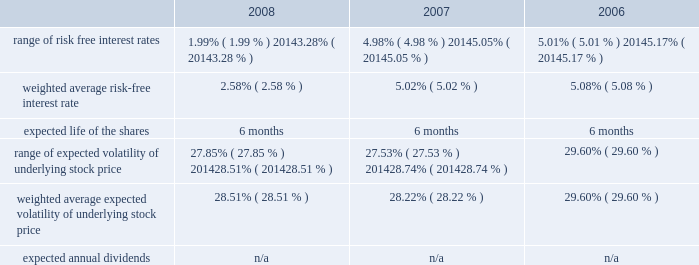American tower corporation and subsidiaries notes to consolidated financial statements 2014 ( continued ) from december 1 through may 31 of each year .
During the 2008 , 2007 and 2006 offering periods employees purchased 55764 , 48886 and 53210 shares , respectively , at weighted average prices per share of $ 30.08 , $ 33.93 and $ 24.98 , respectively .
The fair value of the espp offerings is estimated on the offering period commencement date using a black-scholes pricing model with the expense recognized over the expected life , which is the six month offering period over which employees accumulate payroll deductions to purchase the company 2019s common stock .
The weighted average fair value for the espp shares purchased during 2008 , 2007 and 2006 were $ 7.89 , $ 9.09 and $ 6.79 , respectively .
At december 31 , 2008 , 8.8 million shares remain reserved for future issuance under the plan .
Key assumptions used to apply this pricing model for the years ended december 31 , are as follows: .
13 .
Stockholders 2019 equity warrants 2014in january 2003 , the company issued warrants to purchase approximately 11.4 million shares of its common stock in connection with an offering of 808000 units , each consisting of $ 1000 principal amount at maturity of ati 12.25% ( 12.25 % ) senior subordinated discount notes due 2008 and a warrant to purchase 14.0953 shares of the company 2019s common stock .
These warrants became exercisable on january 29 , 2006 at an exercise price of $ 0.01 per share .
As these warrants expired on august 1 , 2008 , none were outstanding as of december 31 , in august 2005 , the company completed its merger with spectrasite , inc .
And assumed outstanding warrants to purchase shares of spectrasite , inc .
Common stock .
As of the merger completion date , each warrant was exercisable for two shares of spectrasite , inc .
Common stock at an exercise price of $ 32 per warrant .
Upon completion of the merger , each warrant to purchase shares of spectrasite , inc .
Common stock automatically converted into a warrant to purchase shares of the company 2019s common stock , such that upon exercise of each warrant , the holder has a right to receive 3.575 shares of the company 2019s common stock in lieu of each share of spectrasite , inc .
Common stock that would have been receivable under each assumed warrant prior to the merger .
Upon completion of the company 2019s merger with spectrasite , inc. , these warrants were exercisable for approximately 6.8 million shares of common stock .
Of these warrants , warrants to purchase approximately 1.8 million and 2.0 million shares of common stock remained outstanding as of december 31 , 2008 and 2007 , respectively .
These warrants will expire on february 10 , 2010 .
Stock repurchase programs 2014during the year ended december 31 , 2008 , the company repurchased an aggregate of approximately 18.3 million shares of its common stock for an aggregate of $ 697.1 million , including commissions and fees , pursuant to its publicly announced stock repurchase programs , as described below. .
For ati what was the percent of the increase in the shares bought by employees from 2007 to 2008? 
Computations: ((55764 - 48886) / 48886)
Answer: 0.14069. 